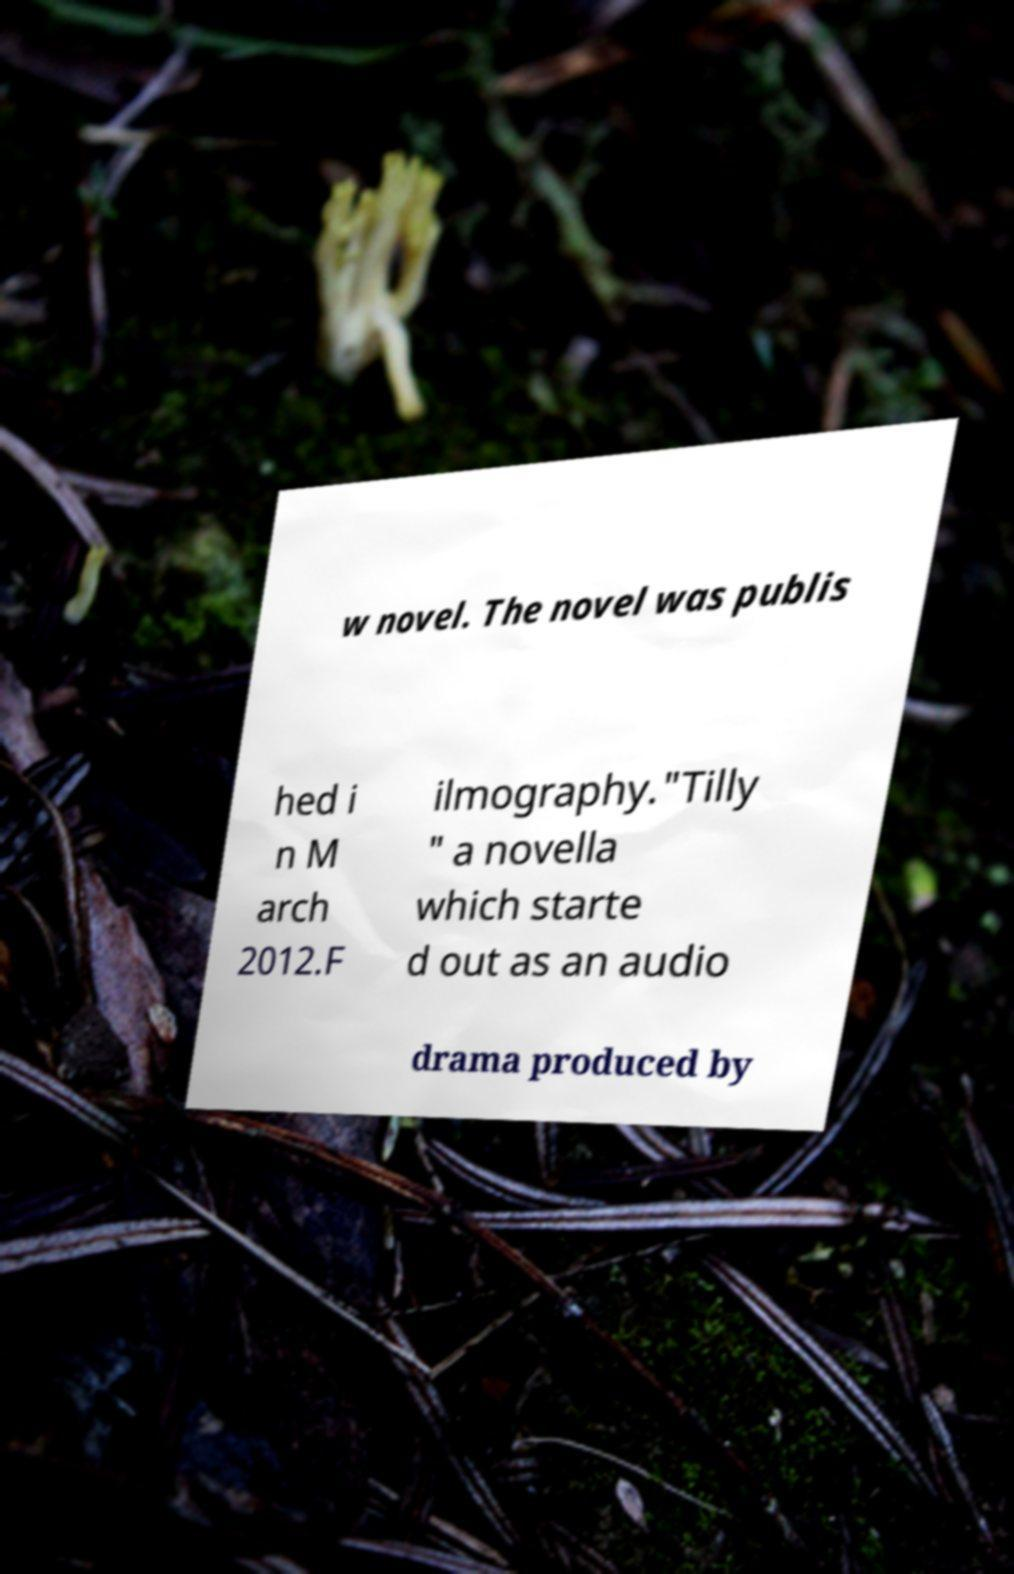Can you accurately transcribe the text from the provided image for me? w novel. The novel was publis hed i n M arch 2012.F ilmography."Tilly " a novella which starte d out as an audio drama produced by 